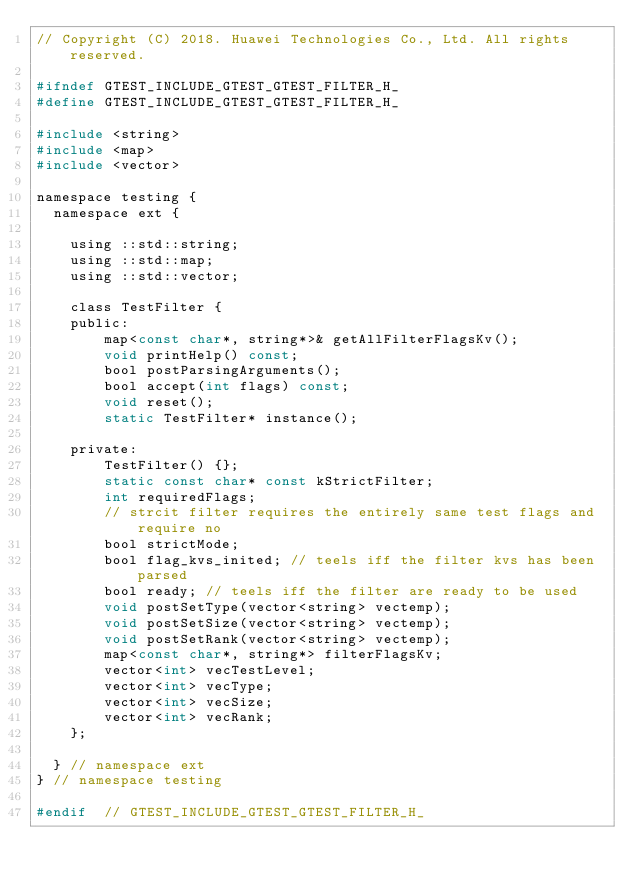<code> <loc_0><loc_0><loc_500><loc_500><_C_>// Copyright (C) 2018. Huawei Technologies Co., Ltd. All rights reserved.

#ifndef GTEST_INCLUDE_GTEST_GTEST_FILTER_H_
#define GTEST_INCLUDE_GTEST_GTEST_FILTER_H_

#include <string>
#include <map>
#include <vector>

namespace testing {
  namespace ext {

    using ::std::string;
    using ::std::map;
    using ::std::vector;

    class TestFilter {
    public:
        map<const char*, string*>& getAllFilterFlagsKv();
        void printHelp() const;
        bool postParsingArguments();
        bool accept(int flags) const;
        void reset();
        static TestFilter* instance();

    private:
        TestFilter() {};
        static const char* const kStrictFilter;
        int requiredFlags;
        // strcit filter requires the entirely same test flags and require no
        bool strictMode;
        bool flag_kvs_inited; // teels iff the filter kvs has been parsed
        bool ready; // teels iff the filter are ready to be used
        void postSetType(vector<string> vectemp);
        void postSetSize(vector<string> vectemp);
        void postSetRank(vector<string> vectemp);
        map<const char*, string*> filterFlagsKv;
        vector<int> vecTestLevel;
        vector<int> vecType;
        vector<int> vecSize;
        vector<int> vecRank;
    };

  } // namespace ext
} // namespace testing

#endif  // GTEST_INCLUDE_GTEST_GTEST_FILTER_H_

</code> 